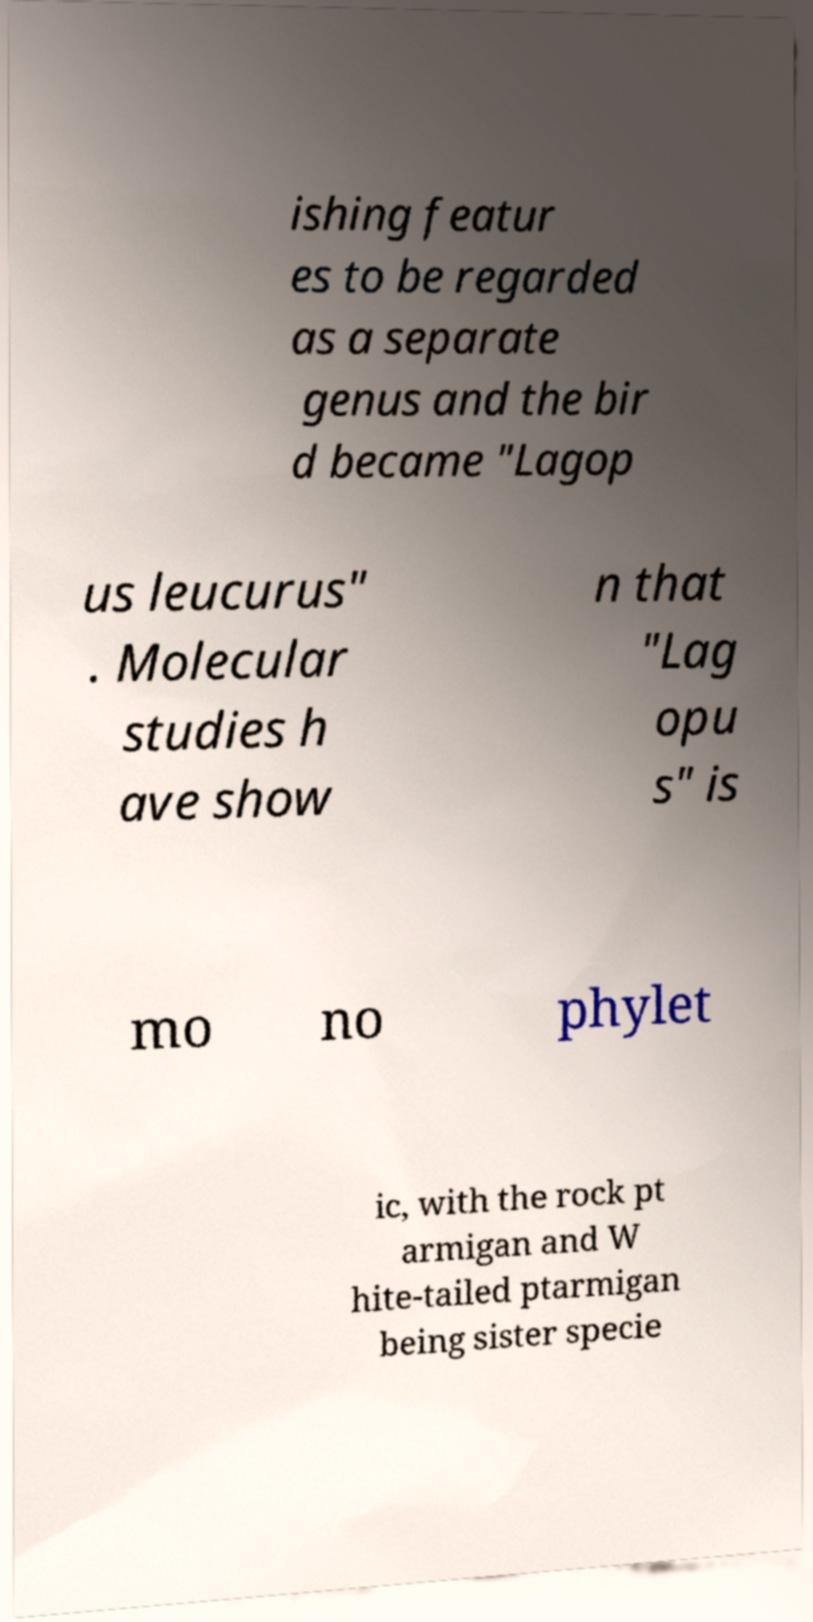Please identify and transcribe the text found in this image. ishing featur es to be regarded as a separate genus and the bir d became "Lagop us leucurus" . Molecular studies h ave show n that "Lag opu s" is mo no phylet ic, with the rock pt armigan and W hite-tailed ptarmigan being sister specie 